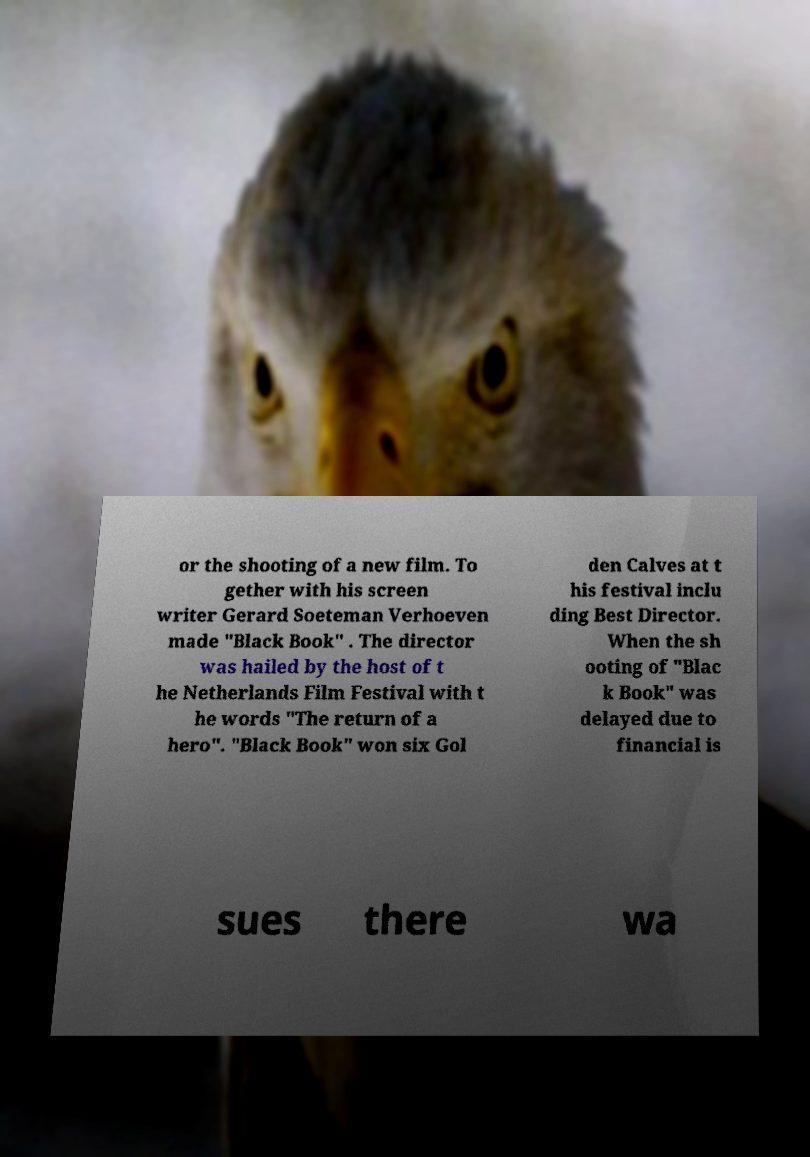I need the written content from this picture converted into text. Can you do that? or the shooting of a new film. To gether with his screen writer Gerard Soeteman Verhoeven made "Black Book" . The director was hailed by the host of t he Netherlands Film Festival with t he words "The return of a hero". "Black Book" won six Gol den Calves at t his festival inclu ding Best Director. When the sh ooting of "Blac k Book" was delayed due to financial is sues there wa 